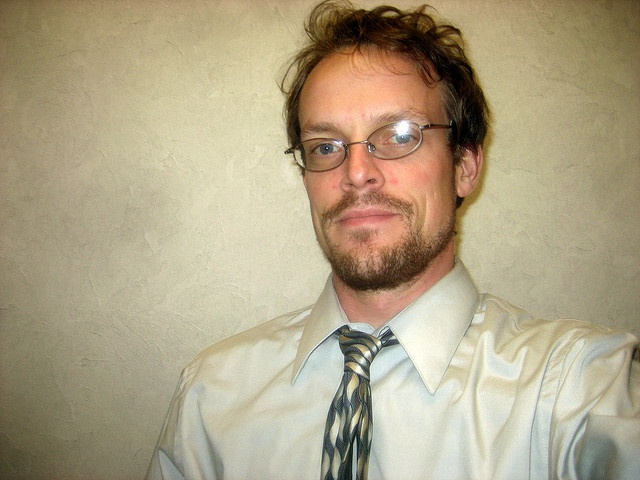Describe the objects in this image and their specific colors. I can see people in olive, beige, darkgray, and tan tones and tie in olive, gray, black, darkgray, and beige tones in this image. 